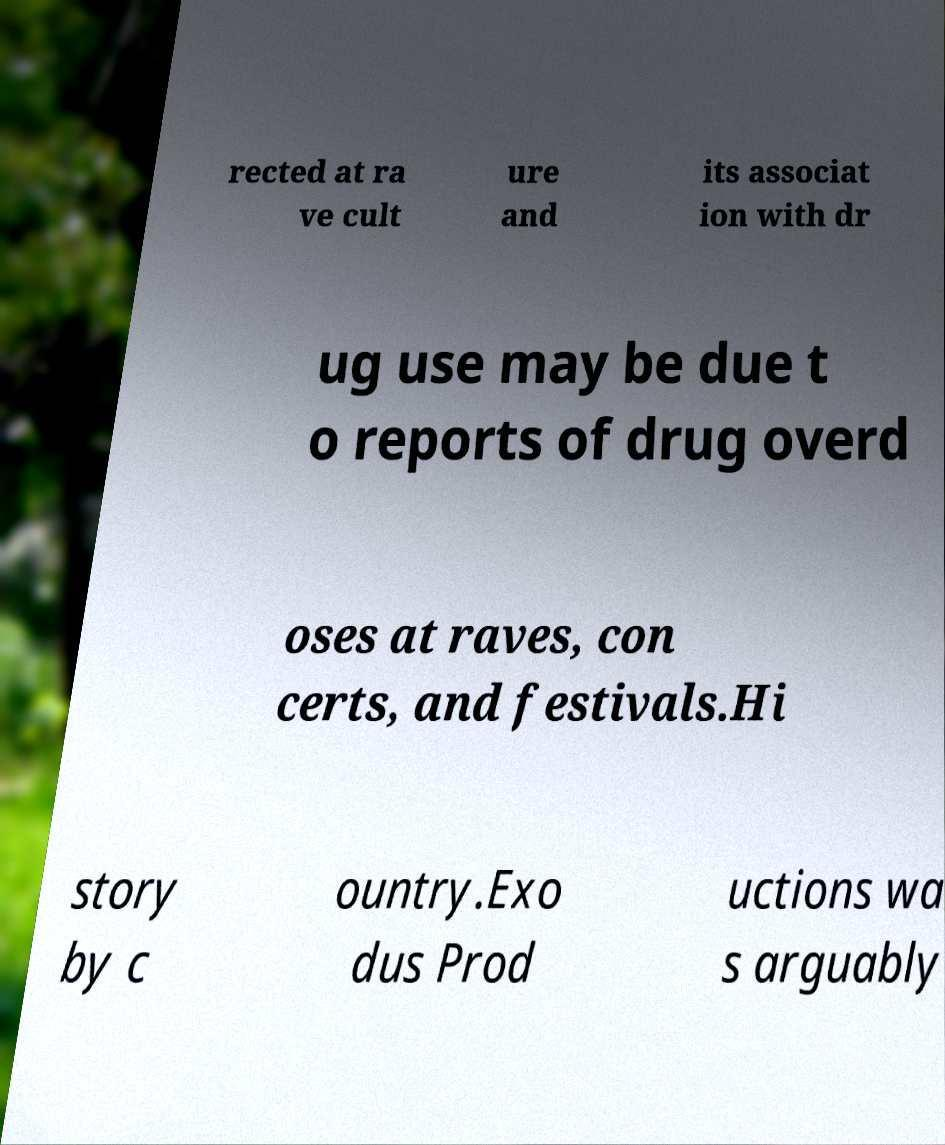Please read and relay the text visible in this image. What does it say? rected at ra ve cult ure and its associat ion with dr ug use may be due t o reports of drug overd oses at raves, con certs, and festivals.Hi story by c ountry.Exo dus Prod uctions wa s arguably 